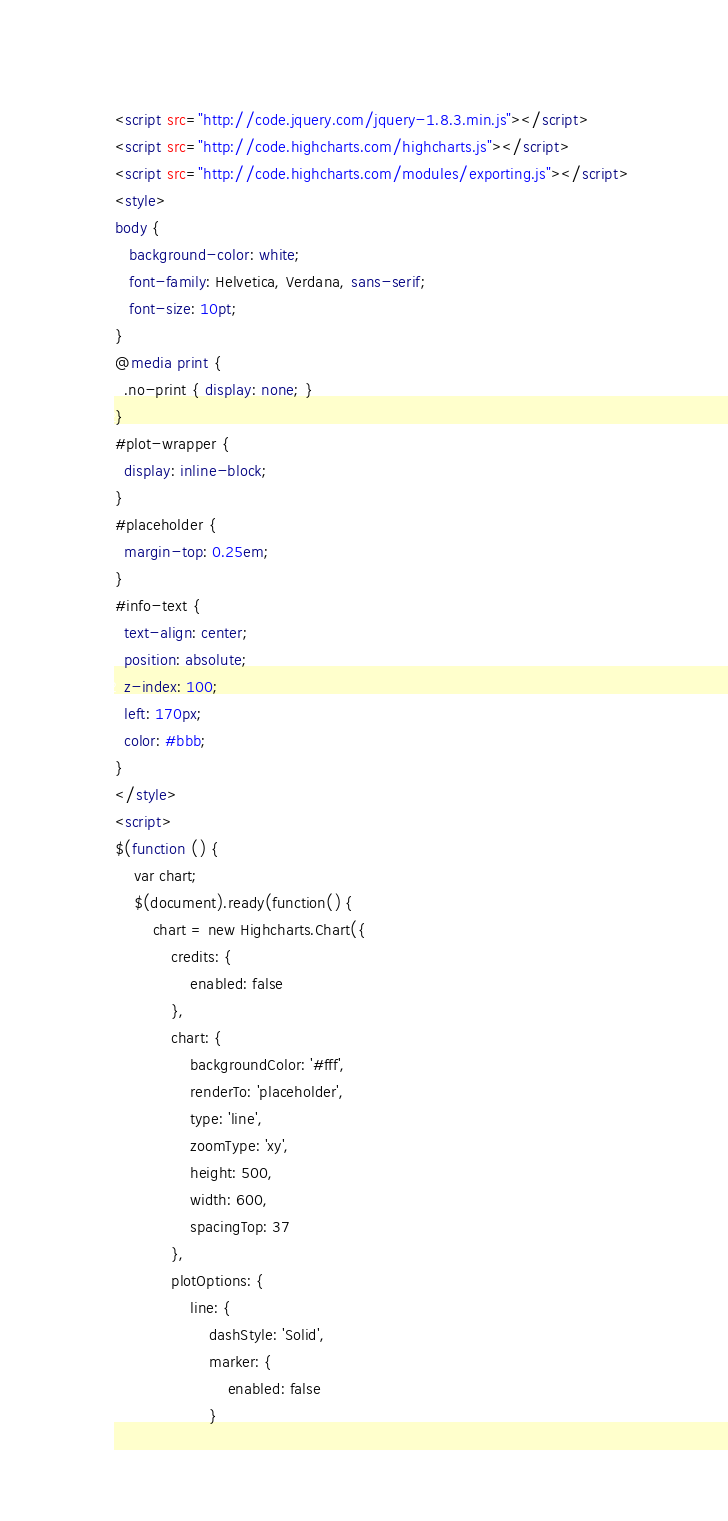Convert code to text. <code><loc_0><loc_0><loc_500><loc_500><_HTML_>
<script src="http://code.jquery.com/jquery-1.8.3.min.js"></script>
<script src="http://code.highcharts.com/highcharts.js"></script>
<script src="http://code.highcharts.com/modules/exporting.js"></script>
<style>
body {
   background-color: white;
   font-family: Helvetica, Verdana, sans-serif;
   font-size: 10pt;
}
@media print {
  .no-print { display: none; }
}
#plot-wrapper {
  display: inline-block;
}
#placeholder {
  margin-top: 0.25em;
}
#info-text {
  text-align: center;
  position: absolute;
  z-index: 100;
  left: 170px;
  color: #bbb;
}
</style>
<script>
$(function () {
    var chart;
    $(document).ready(function() {
        chart = new Highcharts.Chart({
            credits: {
                enabled: false
            },
            chart: {
                backgroundColor: '#fff',
                renderTo: 'placeholder',
                type: 'line',
                zoomType: 'xy',
                height: 500,
                width: 600,
                spacingTop: 37
            },
            plotOptions: {
                line: {
                    dashStyle: 'Solid',
                    marker: {
                        enabled: false
                    }</code> 